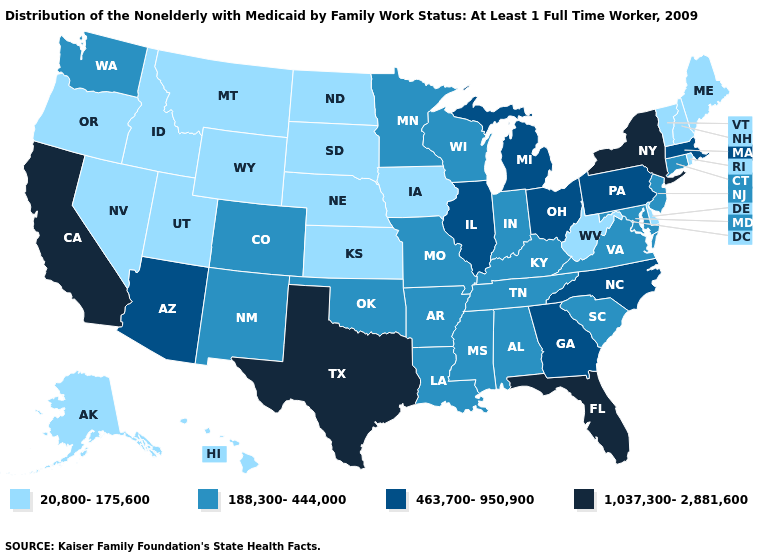What is the value of Alaska?
Short answer required. 20,800-175,600. What is the highest value in the Northeast ?
Give a very brief answer. 1,037,300-2,881,600. What is the value of Idaho?
Answer briefly. 20,800-175,600. What is the value of Florida?
Concise answer only. 1,037,300-2,881,600. What is the highest value in the Northeast ?
Answer briefly. 1,037,300-2,881,600. Name the states that have a value in the range 1,037,300-2,881,600?
Concise answer only. California, Florida, New York, Texas. Name the states that have a value in the range 188,300-444,000?
Concise answer only. Alabama, Arkansas, Colorado, Connecticut, Indiana, Kentucky, Louisiana, Maryland, Minnesota, Mississippi, Missouri, New Jersey, New Mexico, Oklahoma, South Carolina, Tennessee, Virginia, Washington, Wisconsin. What is the value of Hawaii?
Write a very short answer. 20,800-175,600. Among the states that border Mississippi , which have the highest value?
Give a very brief answer. Alabama, Arkansas, Louisiana, Tennessee. Does North Carolina have a higher value than Indiana?
Concise answer only. Yes. What is the highest value in states that border Arizona?
Be succinct. 1,037,300-2,881,600. Name the states that have a value in the range 1,037,300-2,881,600?
Concise answer only. California, Florida, New York, Texas. What is the highest value in states that border New Hampshire?
Short answer required. 463,700-950,900. What is the value of Texas?
Keep it brief. 1,037,300-2,881,600. Name the states that have a value in the range 188,300-444,000?
Keep it brief. Alabama, Arkansas, Colorado, Connecticut, Indiana, Kentucky, Louisiana, Maryland, Minnesota, Mississippi, Missouri, New Jersey, New Mexico, Oklahoma, South Carolina, Tennessee, Virginia, Washington, Wisconsin. 